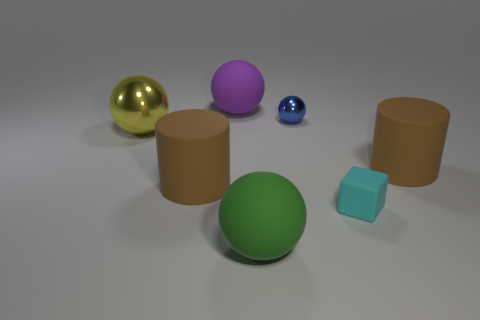Subtract all big yellow spheres. How many spheres are left? 3 Add 1 large yellow balls. How many objects exist? 8 Subtract all purple balls. How many balls are left? 3 Subtract all cylinders. How many objects are left? 5 Subtract 4 spheres. How many spheres are left? 0 Subtract 1 purple spheres. How many objects are left? 6 Subtract all gray blocks. Subtract all cyan balls. How many blocks are left? 1 Subtract all big purple matte objects. Subtract all big yellow metal balls. How many objects are left? 5 Add 1 green rubber balls. How many green rubber balls are left? 2 Add 1 small cyan objects. How many small cyan objects exist? 2 